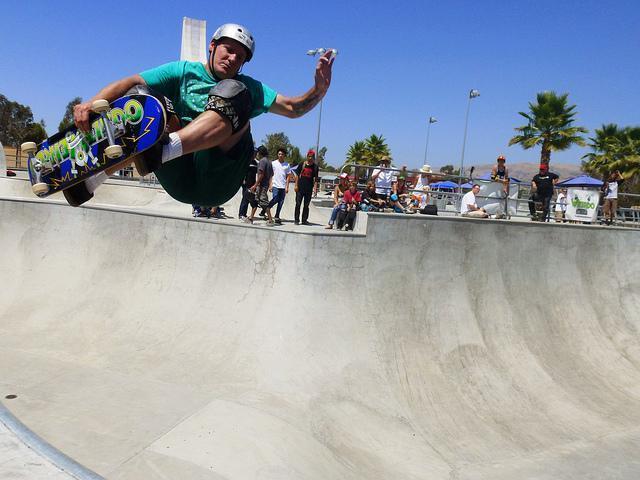How many skateboards are there?
Give a very brief answer. 1. How many people are there?
Give a very brief answer. 2. 